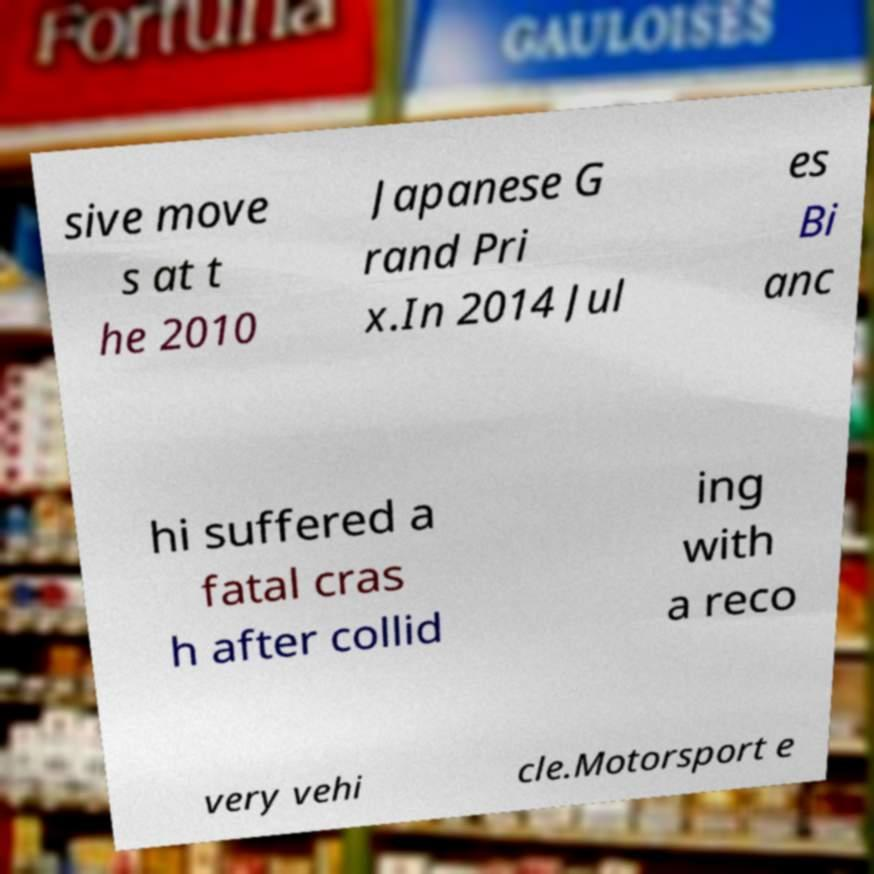Can you read and provide the text displayed in the image?This photo seems to have some interesting text. Can you extract and type it out for me? sive move s at t he 2010 Japanese G rand Pri x.In 2014 Jul es Bi anc hi suffered a fatal cras h after collid ing with a reco very vehi cle.Motorsport e 